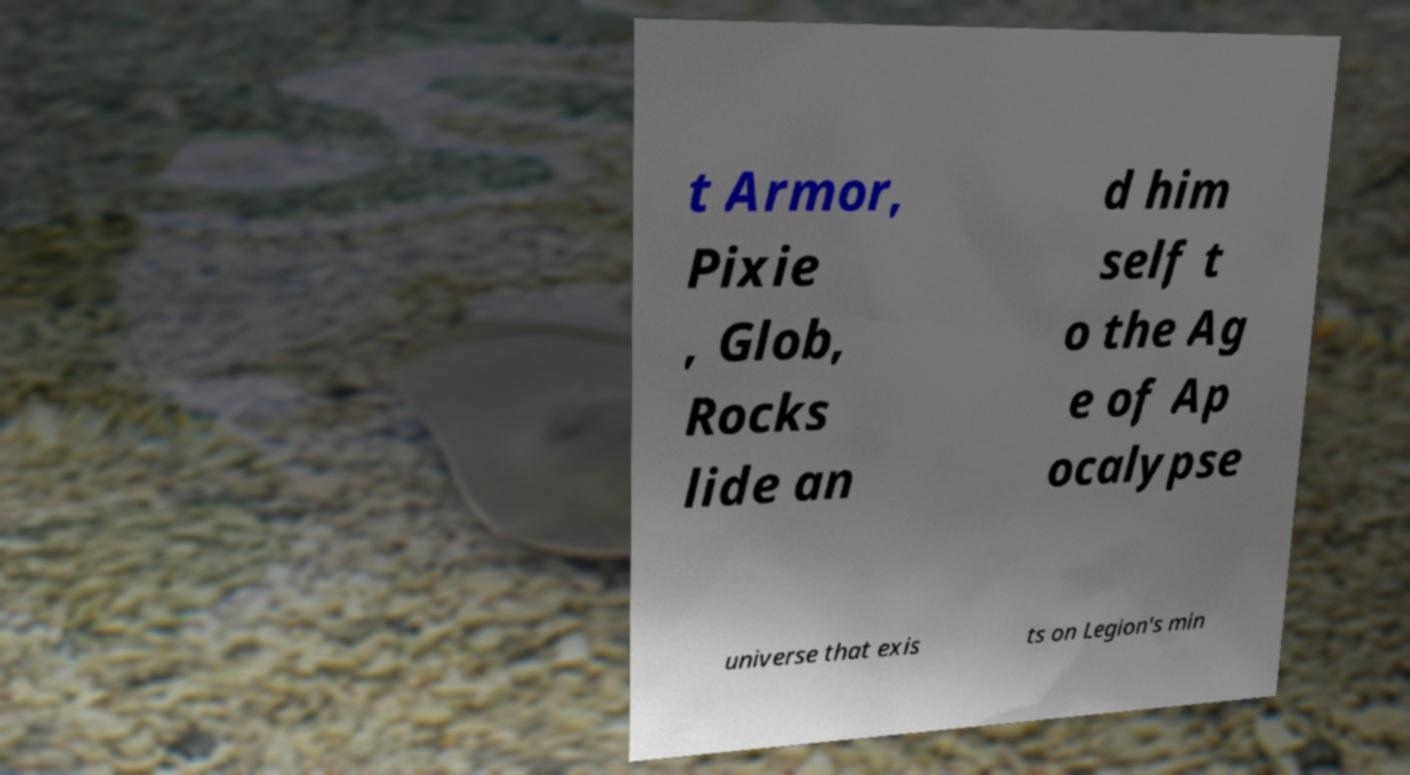Could you assist in decoding the text presented in this image and type it out clearly? t Armor, Pixie , Glob, Rocks lide an d him self t o the Ag e of Ap ocalypse universe that exis ts on Legion's min 